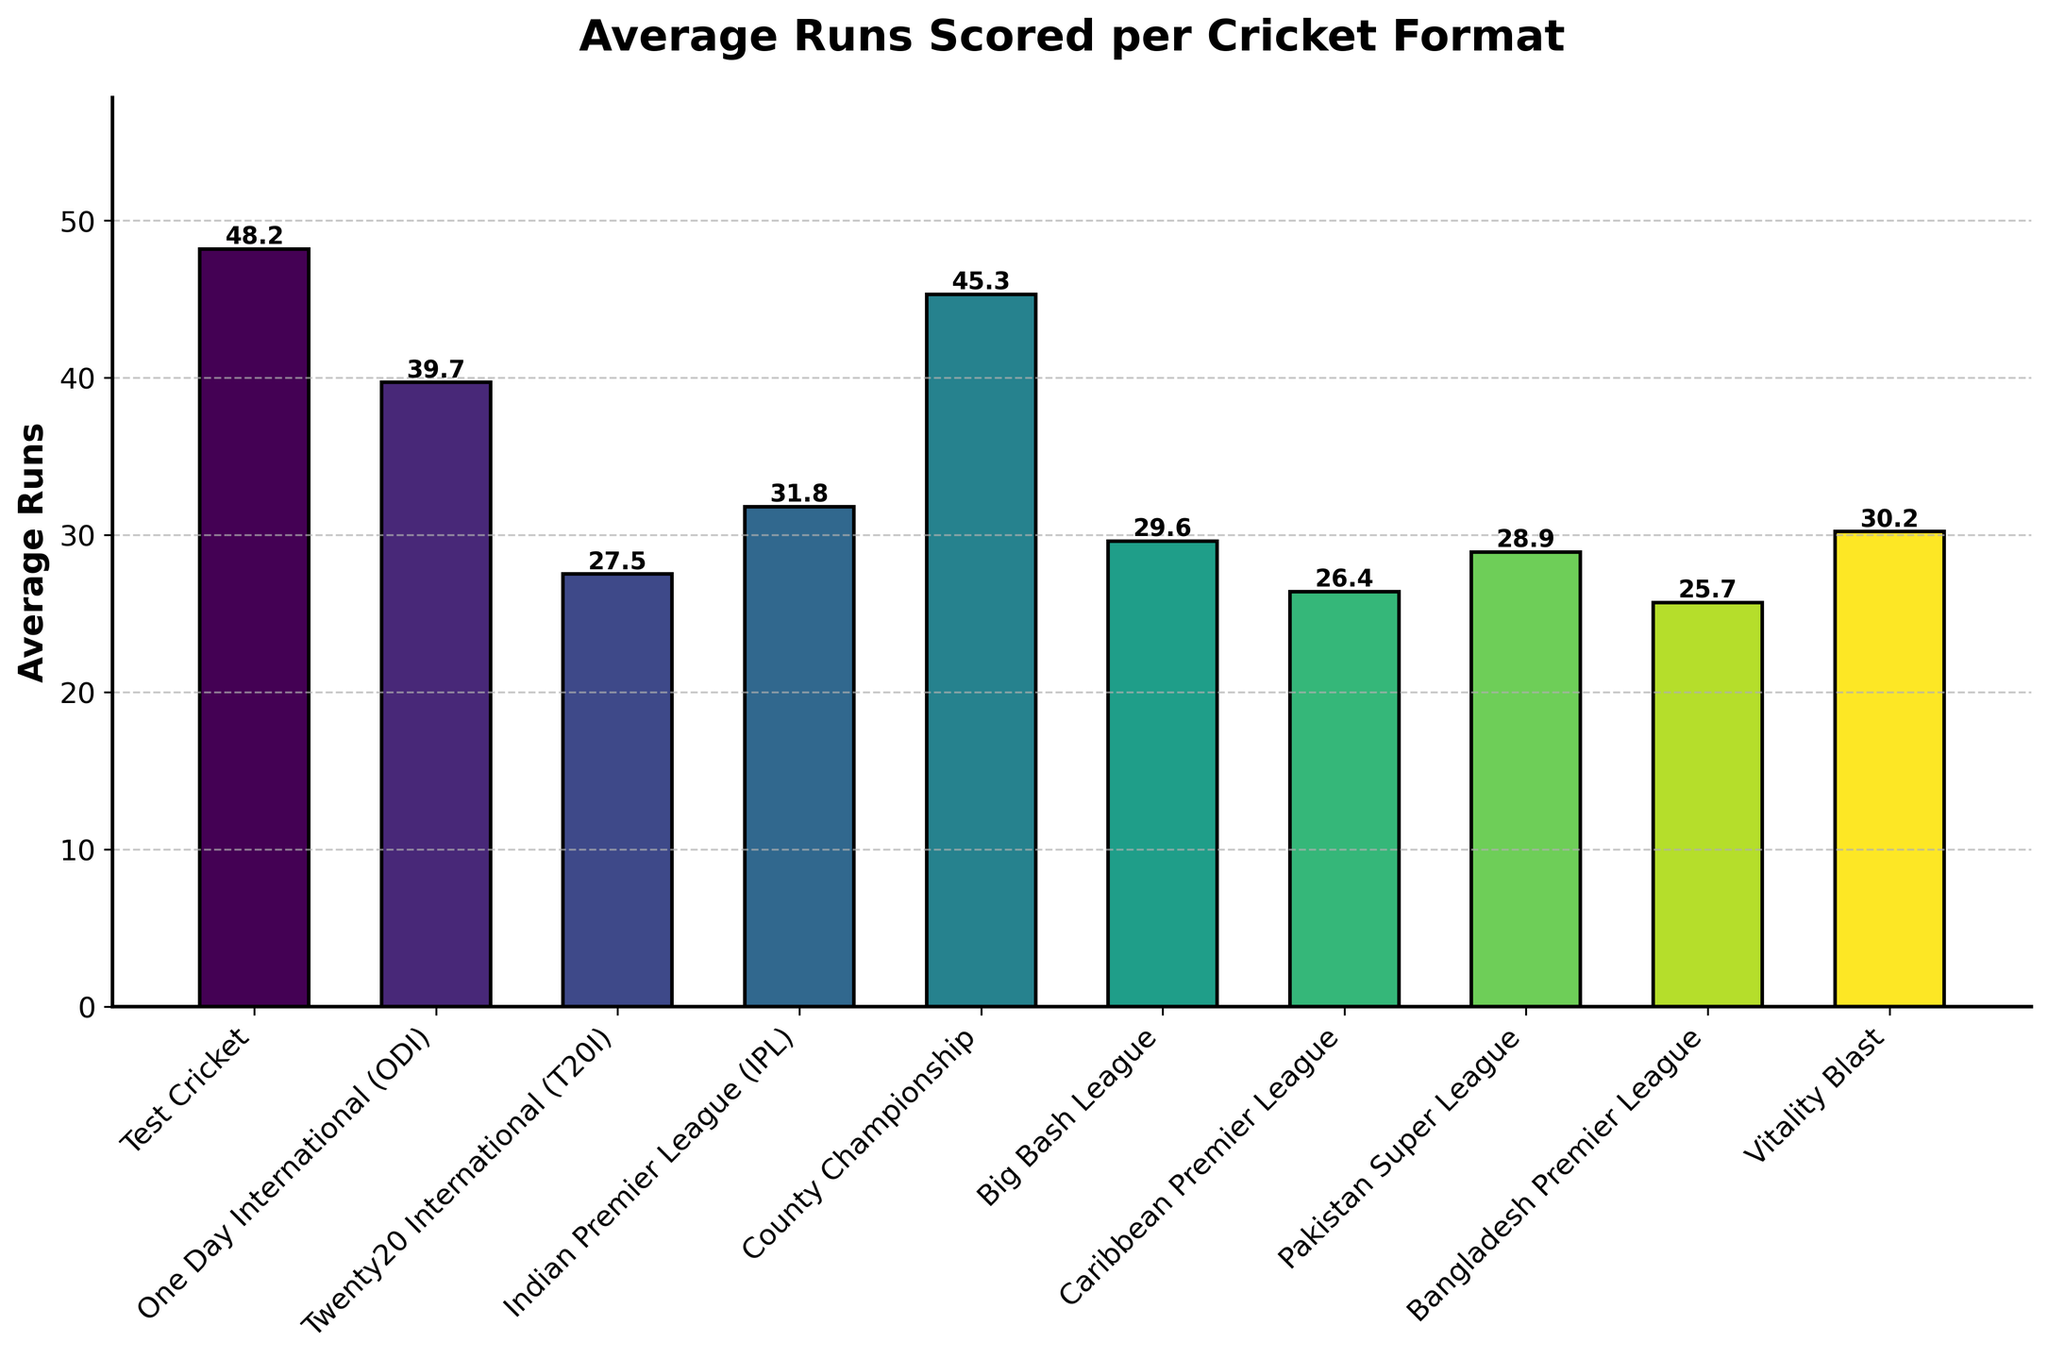Which format has the highest average runs? The bar for Test Cricket is the tallest among all, indicating the highest average runs.
Answer: Test Cricket Which format has the lowest average runs? The shortest bar represents the lowest average runs, which is for the Bangladesh Premier League.
Answer: Bangladesh Premier League What is the difference in average runs between Test Cricket and T20I? The average runs for Test Cricket is 48.2 and for T20I is 27.5. The difference is calculated as 48.2 - 27.5
Answer: 20.7 Is the average runs for ODI greater than or less than IPL? The average runs for ODI is 39.7, while for IPL it is 31.8. Comparing these values, 39.7 is greater than 31.8.
Answer: Greater What is the average of the average runs for all formats combined? Sum the average runs for each format: 48.2 + 39.7 + 27.5 + 31.8 + 45.3 + 29.6 + 26.4 + 28.9 + 25.7 + 30.2 = 333.3. Divide by the number of formats (10): 333.3 / 10
Answer: 33.3 Between County Championship and Vitality Blast, which format has a higher average runs? The average runs for County Championship is 45.3, while for Vitality Blast it is 30.2. Comparing these values, 45.3 is higher than 30.2.
Answer: County Championship What is the combined average runs for all T20-based leagues (T20I, IPL, BBL, CPL, PSL, BPL, Vitality Blast)? Sum the average runs for T20I, IPL, BBL, CPL, PSL, BPL, and Vitality Blast: 27.5 + 31.8 + 29.6 + 26.4 + 28.9 + 25.7 + 30.2 = 200.1
Answer: 200.1 What is the difference in average runs between the format with the highest average and the format with the second-highest average? The highest average runs is in Test Cricket (48.2) and the second-highest average runs is in County Championship (45.3). The difference is 48.2 - 45.3
Answer: 2.9 Which two formats have the closest average runs? Compare the difference of average runs between each pair of formats. The closest average runs are between Pakistan Super League (28.9) and Big Bash League (29.6), with a difference of 0.7.
Answer: Pakistan Super League and Big Bash League 